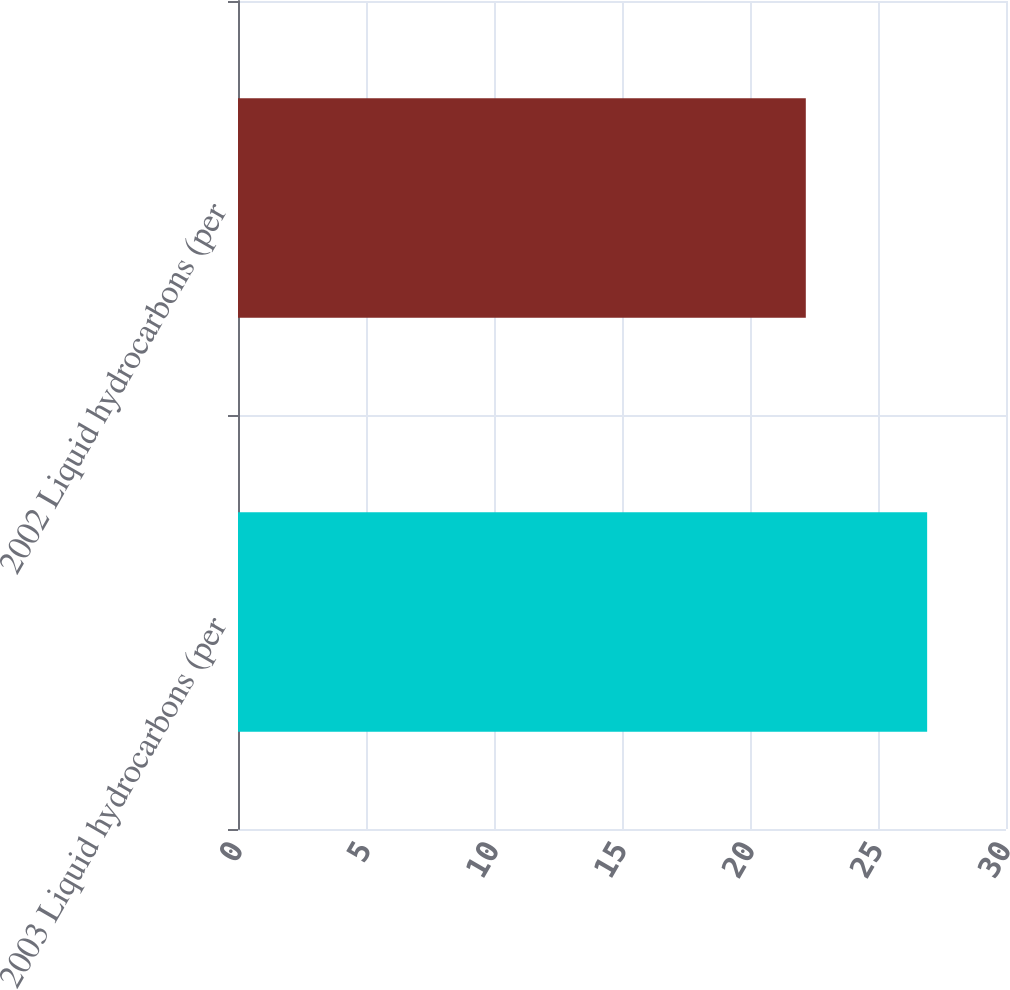Convert chart to OTSL. <chart><loc_0><loc_0><loc_500><loc_500><bar_chart><fcel>2003 Liquid hydrocarbons (per<fcel>2002 Liquid hydrocarbons (per<nl><fcel>26.92<fcel>22.18<nl></chart> 